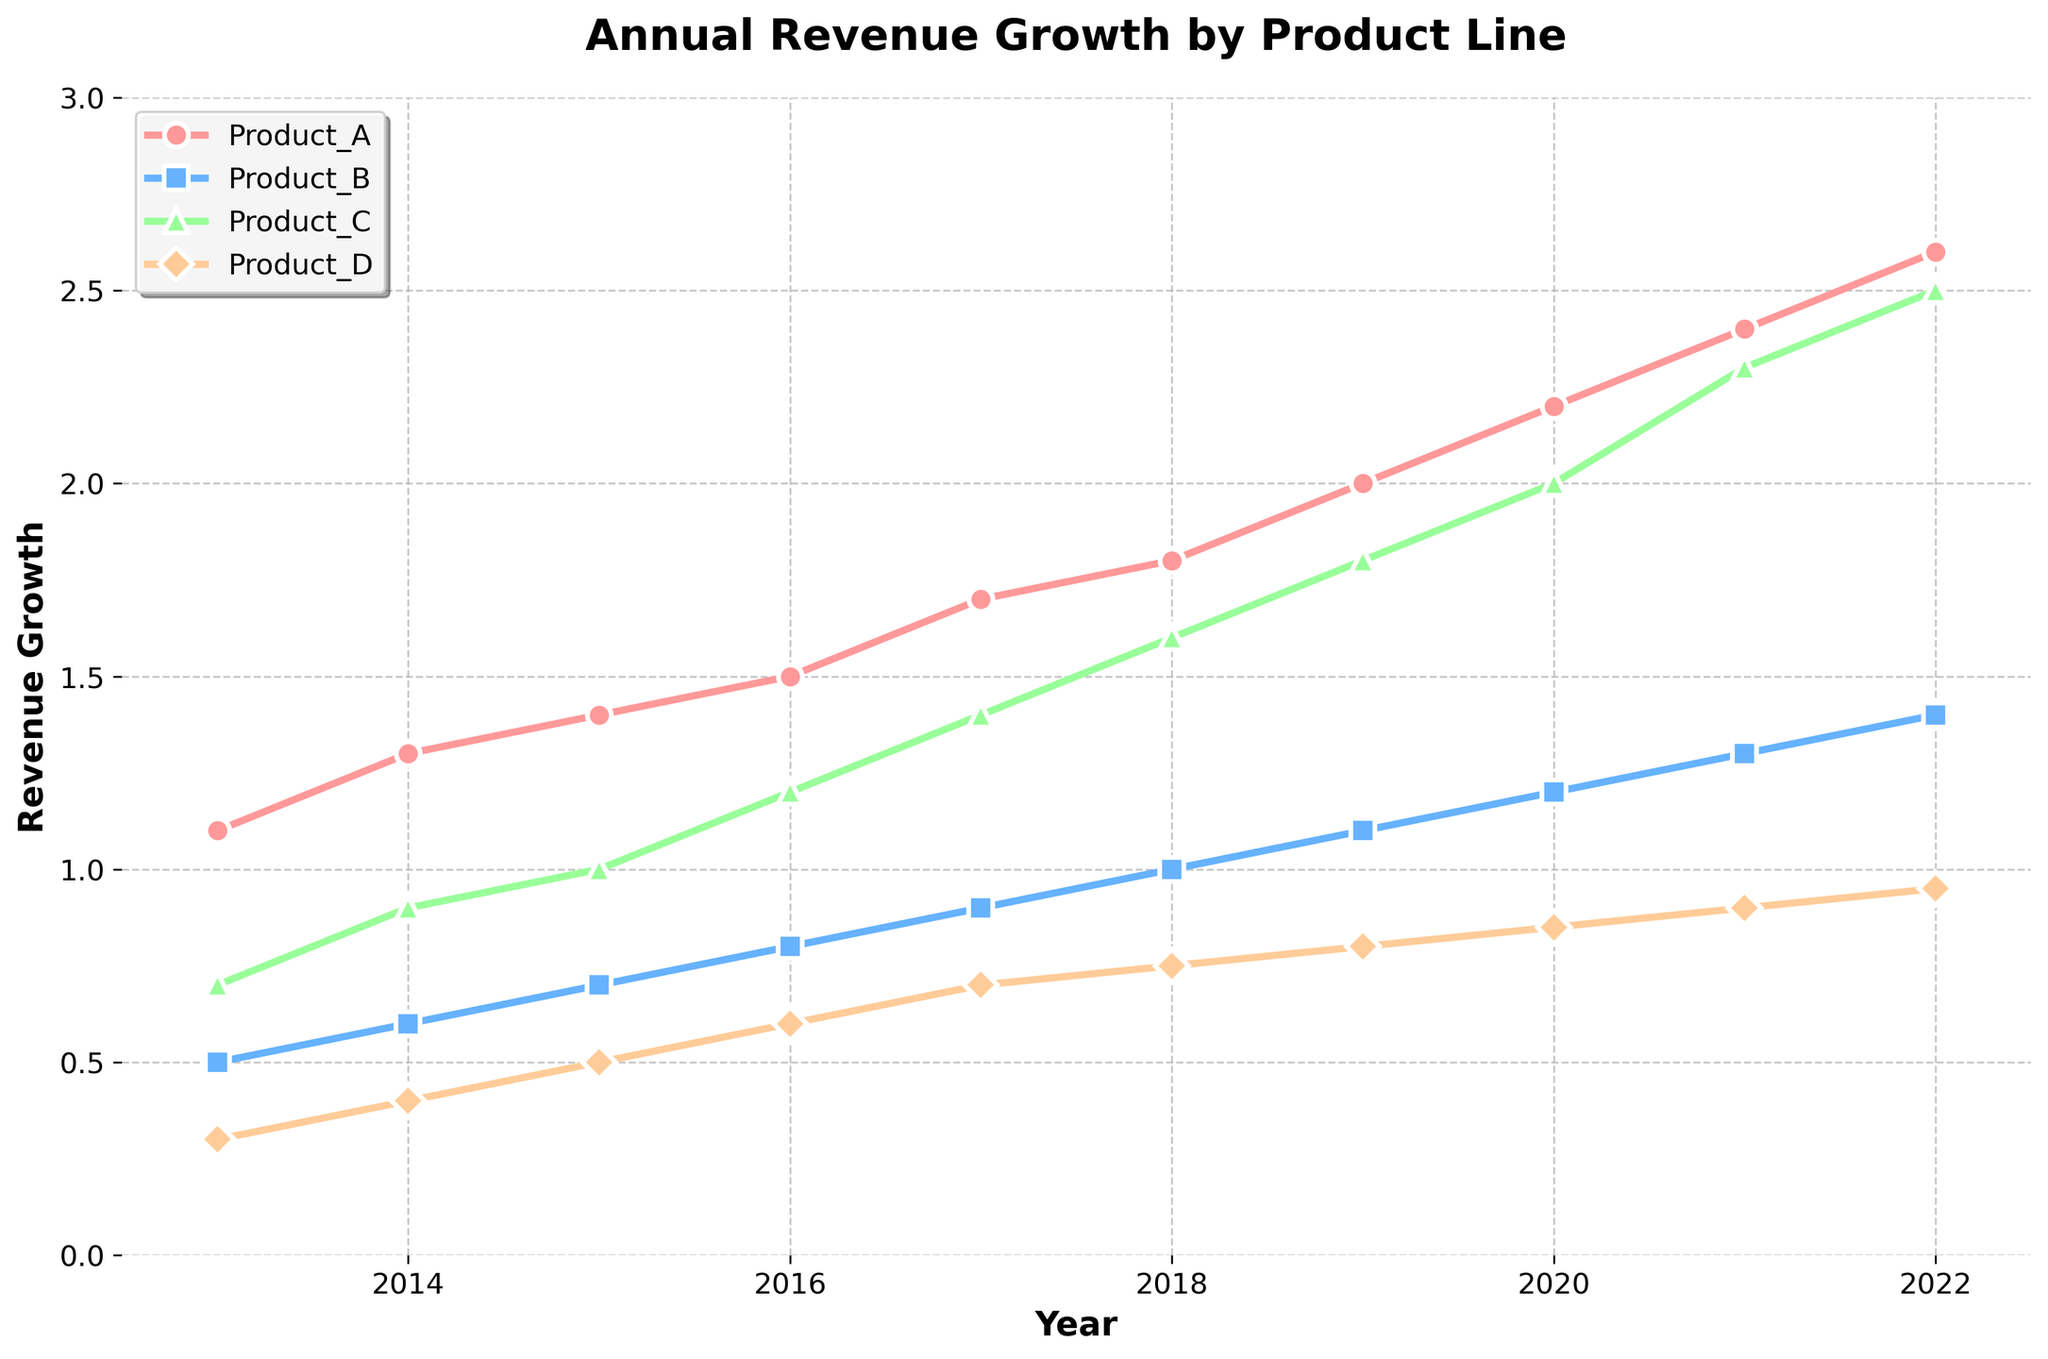What is the title of the figure? The title is usually displayed at the top of the figure. In this case, the title says "Annual Revenue Growth by Product Line".
Answer: Annual Revenue Growth by Product Line What does the y-axis represent? The y-axis label indicates what is being measured. In this figure, it reads "Revenue Growth".
Answer: Revenue Growth How did Product C perform in 2022 compared to 2020? To determine this, locate the values for Product C in 2022 and 2020 on the plot. In 2022, Product C is at 2.5, and in 2020, it is at 2.0. 2.5 is greater than 2.0.
Answer: Better Which product had the highest revenue growth in 2017? Find the year 2017 on the x-axis and look at the corresponding data points for each product. Product C has a value of 1.4, which is higher than the others.
Answer: Product C Between which years did Product D show the most significant growth? Observe the trend for Product D across all years. Compare the increments each year and note the most significant increase. The jump from 2017 (0.7) to 2018 (0.75) transpires to be the highest relative increase.
Answer: 2017 to 2018 In which year did Product A have a revenue growth of 1.1? Locate the value 1.1 on the y-axis and then find the corresponding year along the x-axis for Product A. This value is at 2013.
Answer: 2013 What was the total revenue growth for all products combined in 2019? Sum the values of all product lines in 2019: Product A (2.0) + Product B (1.1) + Product C (1.8) + Product D (0.8) = 5.7.
Answer: 5.7 Which product exhibited the least consistent growth pattern over the decade? Examine the trends of each product, noting any fluctuations. Product D shows the most variability and least consistent growth rate.
Answer: Product D On average, how much did Product B's revenue grow per year? Sum the revenue growth values for Product B over the years (0.5 + 0.6 + 0.7 + 0.8 + 0.9 + 1.0 + 1.1 + 1.2 + 1.3 + 1.4 = 9.5) and divide by the number of years (10): 9.5/10 = 0.95.
Answer: 0.95 How does the revenue growth trend of Product A compare to that of Product B? Analyze the trend lines for both products. Product A shows a steeper and more consistent increase in revenue growth compared to Product B.
Answer: More consistent and steeper for Product A 